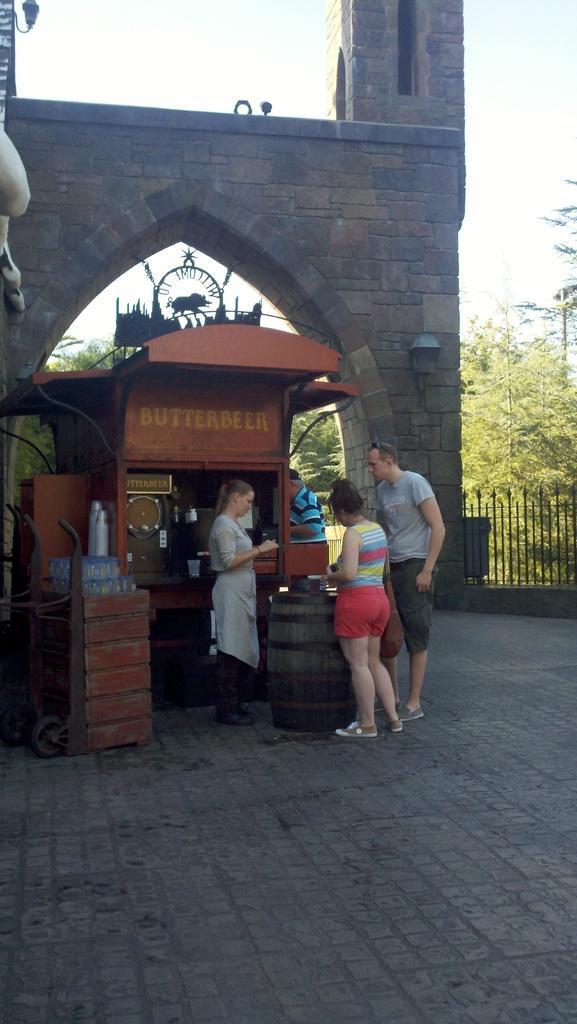Can you describe this image briefly? In this picture, we see four people are standing. Out of them two are men and two are women. The woman in grey dress is holding something in her hands. Behind her, we see a brown color shop like. On the right side, we see a railing. There is an arch. There are trees in the background. At the top of the picture, we see the sky. 